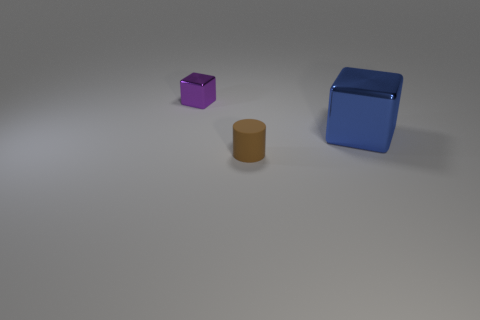Does the big blue object have the same shape as the shiny object that is to the left of the brown cylinder?
Give a very brief answer. Yes. Is there a brown cylinder that is behind the tiny metal thing that is to the left of the matte thing in front of the blue metallic thing?
Keep it short and to the point. No. What number of other objects are there of the same shape as the tiny purple object?
Ensure brevity in your answer.  1. There is a object that is right of the tiny purple cube and to the left of the large blue metallic thing; what is its shape?
Your answer should be very brief. Cylinder. What is the color of the thing that is on the left side of the small thing in front of the metal object on the left side of the blue metallic thing?
Provide a short and direct response. Purple. Are there more large blocks left of the small brown thing than small purple metallic blocks that are in front of the large metal object?
Your response must be concise. No. How many other objects are there of the same size as the purple metallic thing?
Ensure brevity in your answer.  1. What is the thing that is behind the shiny block in front of the tiny metal object made of?
Provide a short and direct response. Metal. Are there any shiny blocks on the left side of the big object?
Ensure brevity in your answer.  Yes. Are there more purple shiny blocks that are in front of the brown matte object than small brown rubber cylinders?
Your response must be concise. No. 